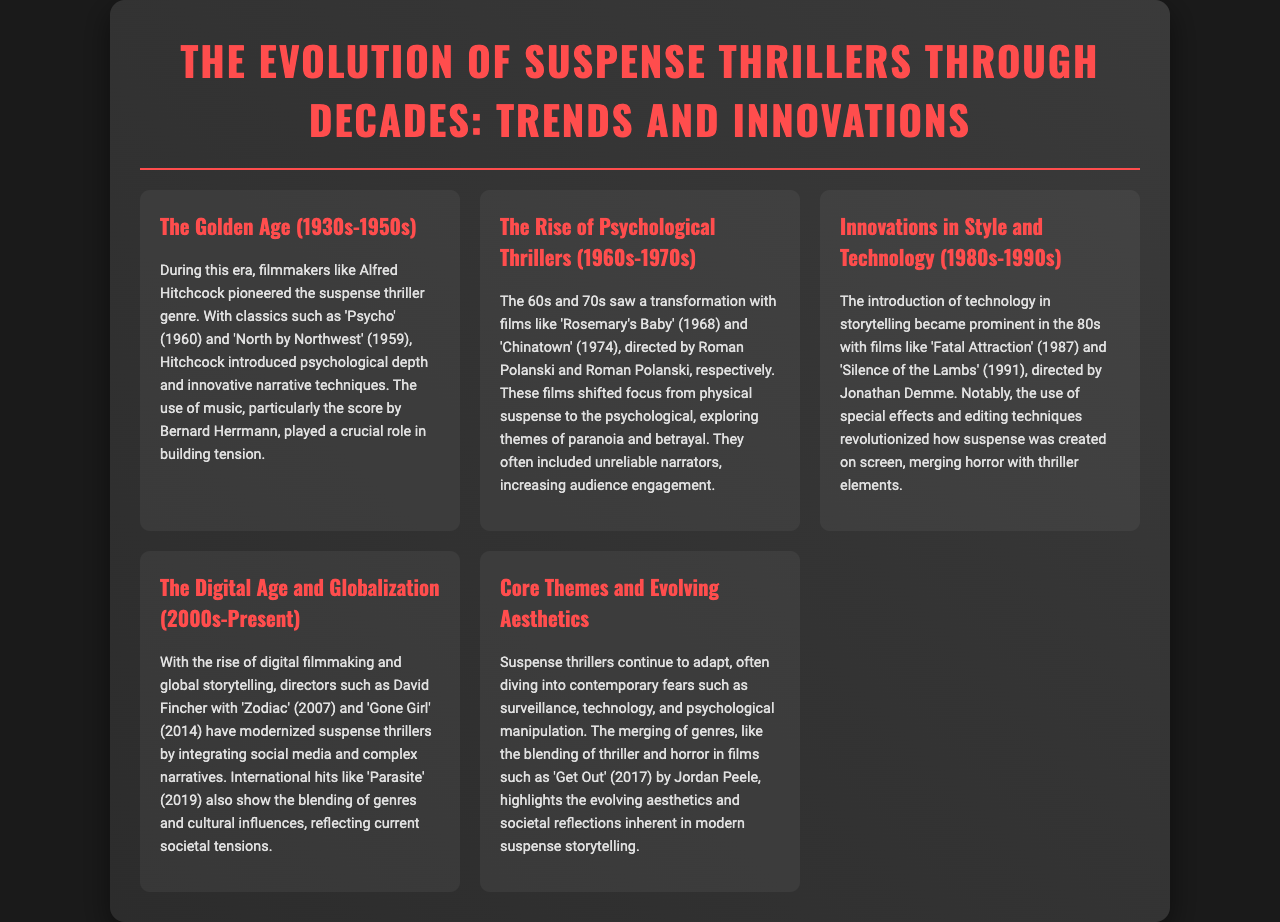What era is known as the Golden Age of suspense thrillers? The document identifies the era from the 1930s to 1950s as the Golden Age of suspense thrillers.
Answer: 1930s-1950s Who directed 'Psycho'? Alfred Hitchcock is mentioned as the filmmaker behind the classic 'Psycho'.
Answer: Alfred Hitchcock What psychological theme is prevalent in films from the 1960s-1970s? The document states that these films explored themes of paranoia and betrayal.
Answer: Paranoia and betrayal Which film is referenced as merging horror with thriller elements in the 1980s? 'Fatal Attraction' is highlighted as a key film in blending horror with thriller elements during this decade.
Answer: Fatal Attraction What two directors are noted for modernizing suspense thrillers in the 2000s? David Fincher and Bong Joon-ho are mentioned as directors who have influenced modern suspense thrillers.
Answer: David Fincher & Bong Joon-ho What has influenced the aesthetics of modern suspense storytelling? The document states that contemporary fears such as surveillance and psychological manipulation have influenced aesthetics.
Answer: Surveillance and psychological manipulation What notable film was released in 2017 by Jordan Peele? 'Get Out' is the film released in 2017 that blends thriller and horror elements.
Answer: Get Out How has globalization affected suspense thrillers according to the document? Global storytelling has been emphasized as a significant aspect of the evolution of suspense thrillers.
Answer: Global storytelling What is the common thread among films from the 2000s to the present? The merging of genres, particularly thriller and horror, is a common aspect of modern films as mentioned in the document.
Answer: Merging of genres 